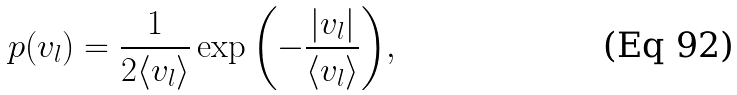<formula> <loc_0><loc_0><loc_500><loc_500>p ( v _ { l } ) = \frac { 1 } { 2 \langle v _ { l } \rangle } \exp { \left ( - \frac { | v _ { l } | } { \langle v _ { l } \rangle } \right ) } ,</formula> 